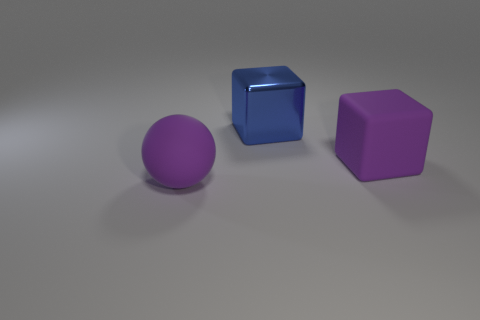Are there the same number of large things to the left of the blue thing and purple blocks?
Your response must be concise. Yes. What is the color of the metal cube that is the same size as the purple matte ball?
Your response must be concise. Blue. Are there any other small metallic things that have the same shape as the blue metal thing?
Offer a terse response. No. There is a big blue thing on the right side of the rubber object that is in front of the matte cube right of the large blue block; what is its material?
Your response must be concise. Metal. How many other things are the same size as the blue block?
Provide a short and direct response. 2. What color is the large matte sphere?
Your answer should be very brief. Purple. What number of shiny objects are either large spheres or small brown things?
Your answer should be compact. 0. Is there anything else that is the same material as the big blue cube?
Offer a terse response. No. There is a matte object to the right of the large purple thing in front of the purple object that is right of the blue metal cube; how big is it?
Keep it short and to the point. Large. There is a thing that is both on the right side of the purple matte sphere and in front of the metallic cube; what size is it?
Your answer should be compact. Large. 